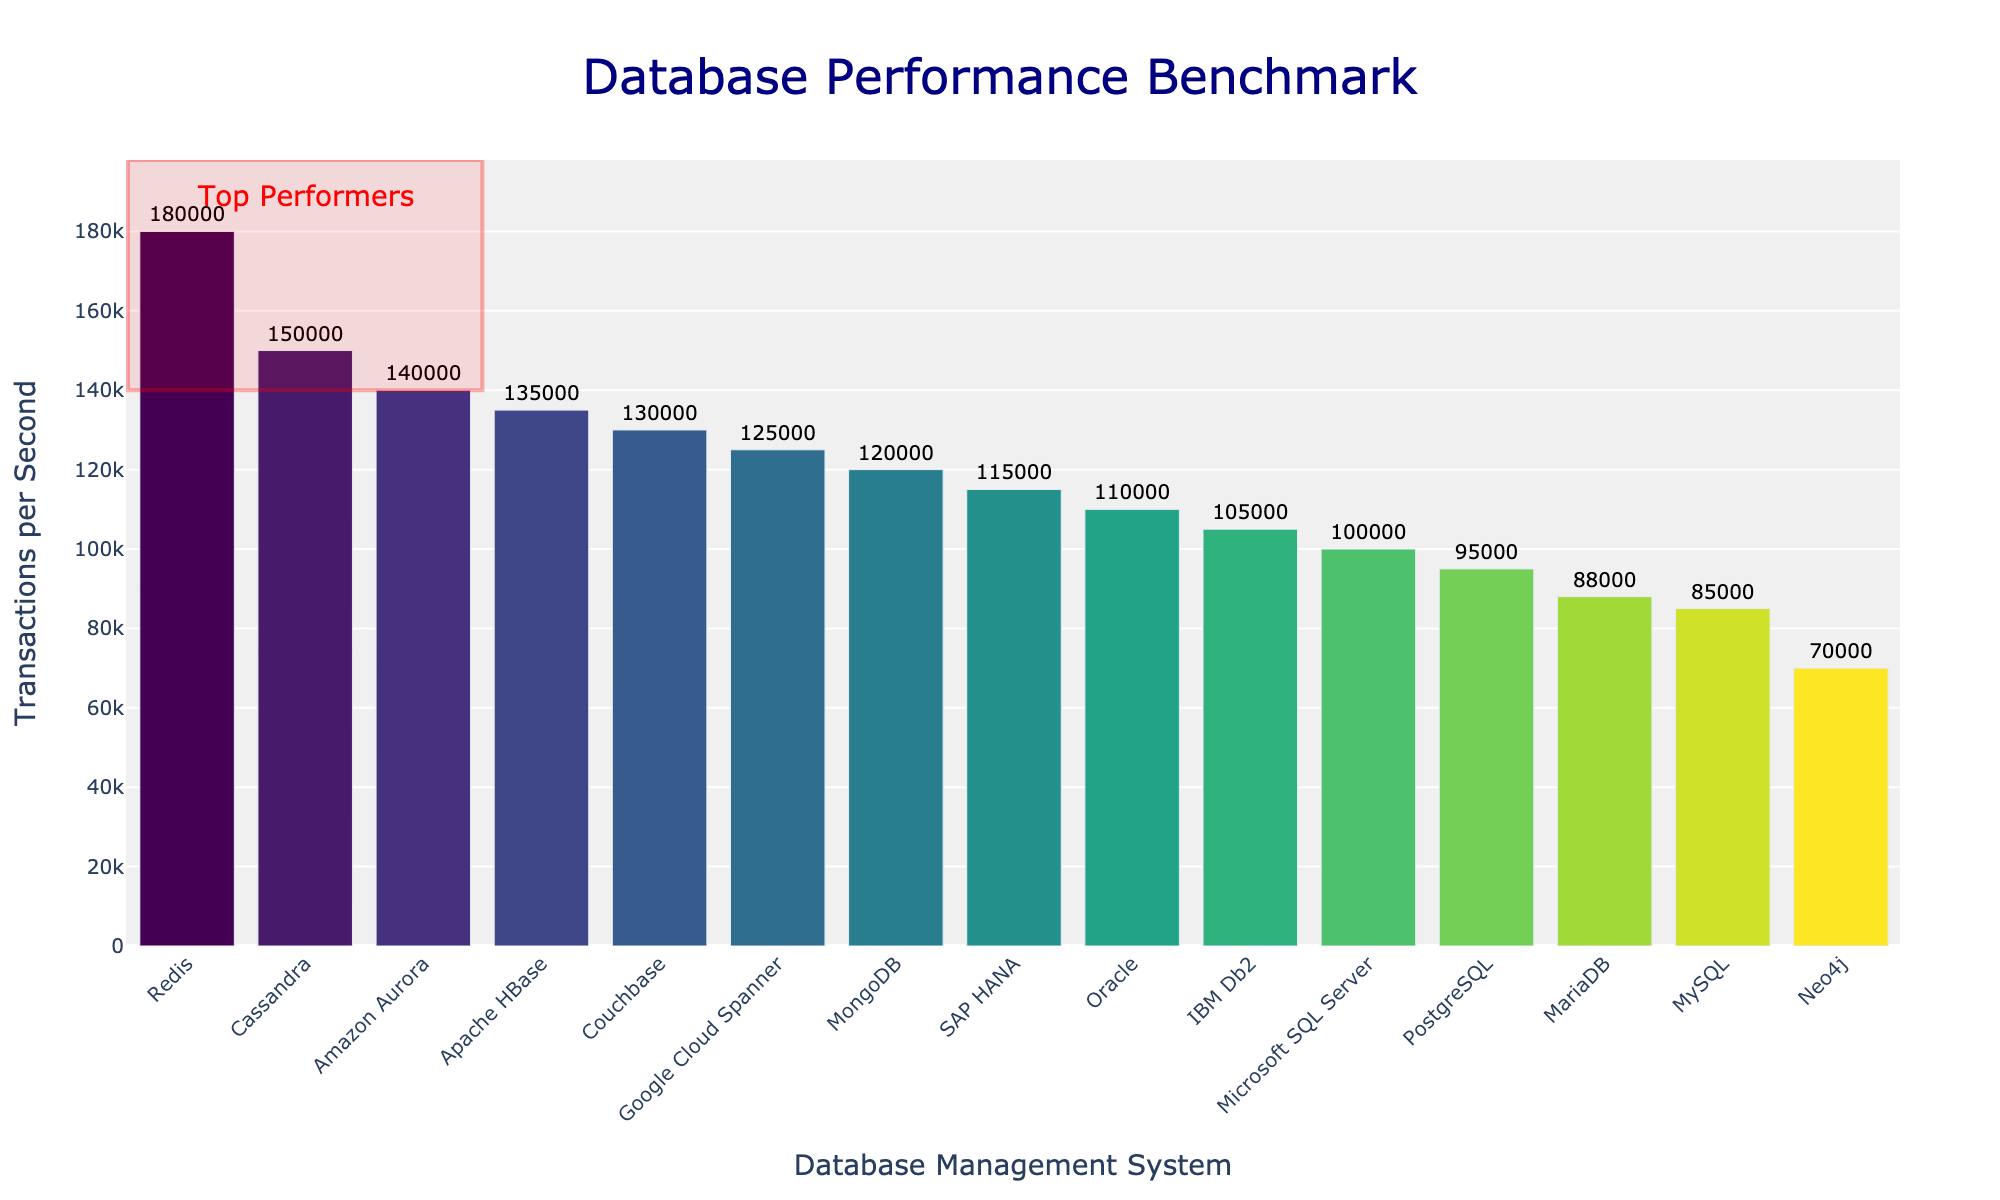Which database has the highest transactions per second (TPS)? The highest bar in the chart represents the database with the highest TPS. Redis has a TPS of 180,000, which is the highest value among all databases shown.
Answer: Redis What is the average transactions per second (TPS) for the top three performers? The top three performers according to the chart are Redis (180,000 TPS), Cassandra (150,000 TPS), and Amazon Aurora (140,000 TPS). The average TPS is calculated as (180,000 + 150,000 + 140,000) / 3 = 470,000 / 3 = 156,666.67 TPS.
Answer: 156,666.67 Which database performs better: PostgreSQL or MariaDB? PostgreSQL has a TPS of 95,000 while MariaDB has a TPS of 88,000. Since 95,000 is greater than 88,000, PostgreSQL performs better than MariaDB.
Answer: PostgreSQL What is the total TPS for the databases marked as "Top Performers"? The databases marked as "Top Performers" in the highlighted section are Redis (180,000), Cassandra (150,000), and Amazon Aurora (140,000). Summing these gives 180,000 + 150,000 + 140,000 = 470,000 TPS.
Answer: 470,000 Which database has the lowest transactions per second (TPS)? The lowest bar in the chart represents the database with the lowest TPS. Neo4j has the lowest TPS at 70,000.
Answer: Neo4j What is the difference in TPS between MongoDB and SAP HANA? According to the chart, MongoDB has 120,000 TPS and SAP HANA has 115,000 TPS. The difference is 120,000 - 115,000 = 5,000 TPS.
Answer: 5,000 Which has higher TPS: Google Cloud Spanner or Couchbase? Google Cloud Spanner has a TPS of 125,000, and Couchbase has a TPS of 130,000. Couchbase has a higher TPS compared to Google Cloud Spanner.
Answer: Couchbase How many databases have a TPS greater than 100,000? From the chart, the databases with TPS greater than 100,000 are MongoDB, Oracle, Microsoft SQL Server, Cassandra, Redis, Couchbase, Amazon Aurora, Google Cloud Spanner, IBM Db2, and SAP HANA, totaling 10 databases.
Answer: 10 What is the combined TPS for Oracle and Microsoft SQL Server? Oracle has a TPS of 110,000 and Microsoft SQL Server has a TPS of 100,000. The combined TPS is 110,000 + 100,000 = 210,000.
Answer: 210,000 Is the TPS of IBM Db2 higher or lower than the average TPS of all databases? First, calculate the average TPS of all databases. Total TPS is the sum of all values: sum([95000, 85000, 120000, 110000, 100000, 150000, 180000, 130000, 88000, 140000, 125000, 105000, 115000, 135000, 70000]) = 1,663,000. Dividing by the 15 databases gives an average TPS of 1,663,000 / 15 ≈ 110,866.67. IBM Db2 has a TPS of 105,000, which is lower than the average TPS of 110,866.67.
Answer: Lower 